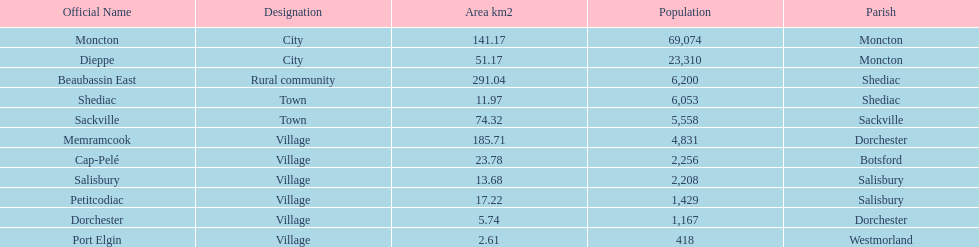Which city has the smallest land area? Port Elgin. 